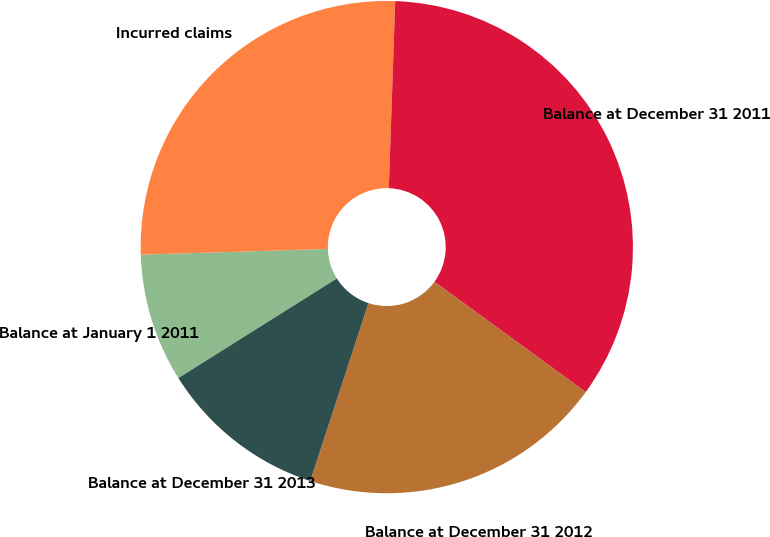Convert chart to OTSL. <chart><loc_0><loc_0><loc_500><loc_500><pie_chart><fcel>Balance at January 1 2011<fcel>Incurred claims<fcel>Balance at December 31 2011<fcel>Balance at December 31 2012<fcel>Balance at December 31 2013<nl><fcel>8.44%<fcel>26.04%<fcel>34.48%<fcel>20.01%<fcel>11.04%<nl></chart> 